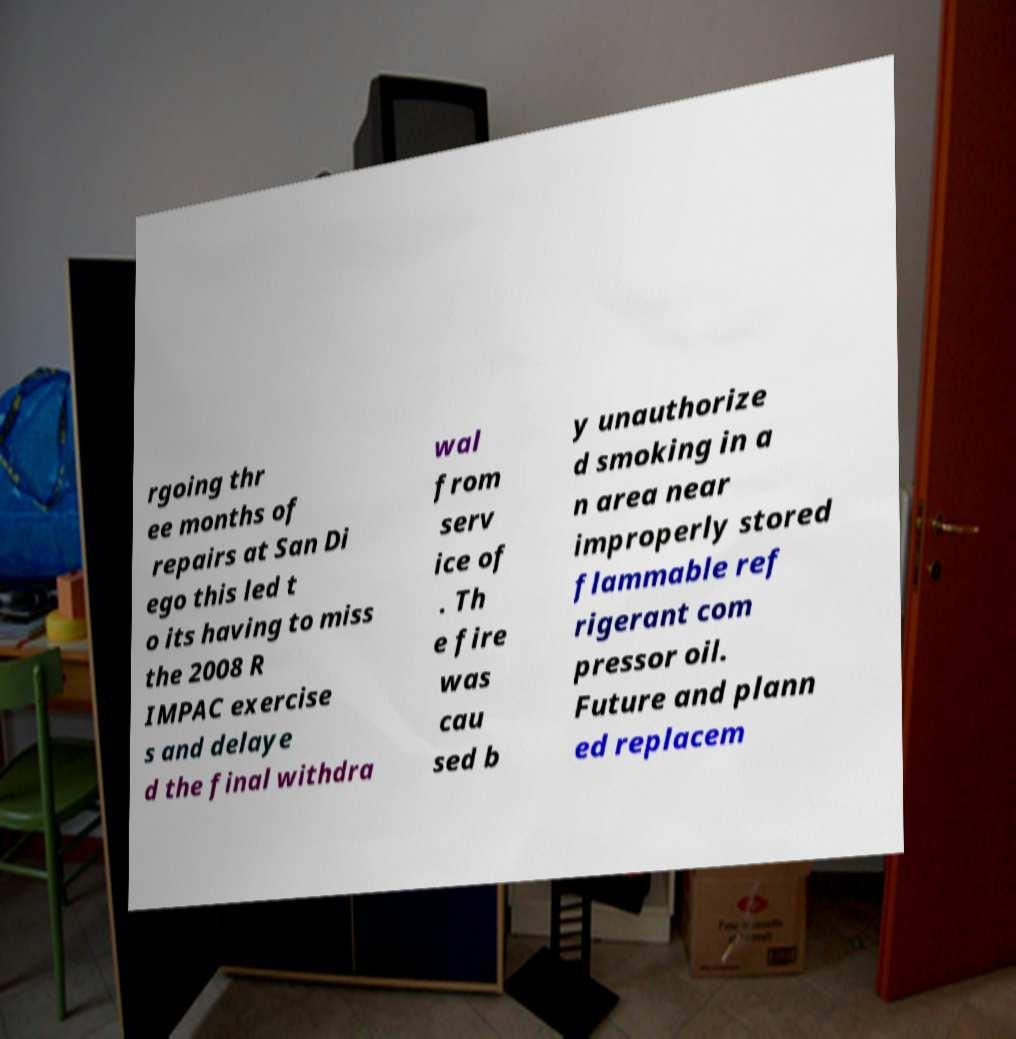For documentation purposes, I need the text within this image transcribed. Could you provide that? rgoing thr ee months of repairs at San Di ego this led t o its having to miss the 2008 R IMPAC exercise s and delaye d the final withdra wal from serv ice of . Th e fire was cau sed b y unauthorize d smoking in a n area near improperly stored flammable ref rigerant com pressor oil. Future and plann ed replacem 